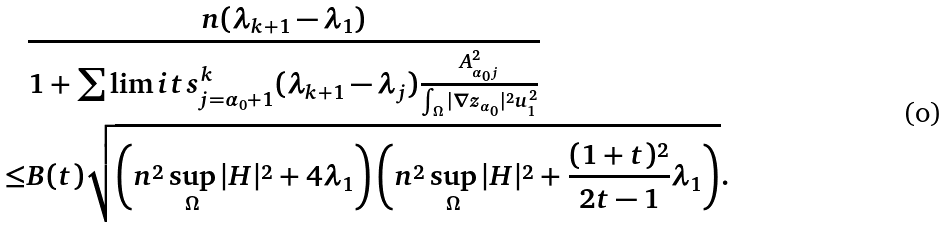Convert formula to latex. <formula><loc_0><loc_0><loc_500><loc_500>& \frac { n ( \lambda _ { k + 1 } - \lambda _ { 1 } ) } { 1 + \sum \lim i t s _ { j = \alpha _ { 0 } + 1 } ^ { k } ( \lambda _ { k + 1 } - \lambda _ { j } ) \frac { A _ { \alpha _ { 0 } j } ^ { 2 } } { \int _ { \Omega } | \nabla z _ { \alpha _ { 0 } } | ^ { 2 } u _ { 1 } ^ { 2 } } } \\ \leq & B ( t ) \sqrt { \left ( n ^ { 2 } \sup _ { \Omega } | H | ^ { 2 } + 4 \lambda _ { 1 } \right ) \left ( n ^ { 2 } \sup _ { \Omega } | H | ^ { 2 } + \frac { ( 1 + t ) ^ { 2 } } { 2 t - 1 } \lambda _ { 1 } \right ) } .</formula> 